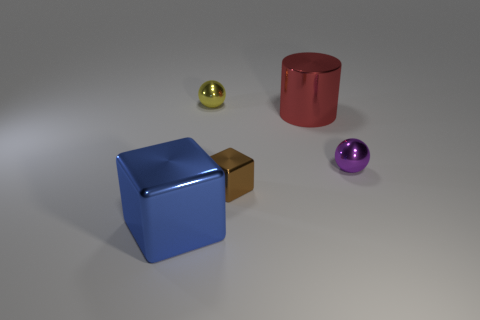Is there anything else that is the same color as the tiny metallic cube?
Make the answer very short. No. The shiny cylinder has what color?
Your response must be concise. Red. What number of metallic things are either tiny yellow spheres or tiny purple balls?
Make the answer very short. 2. The other small thing that is the same shape as the purple shiny thing is what color?
Make the answer very short. Yellow. Are there any green cubes?
Offer a very short reply. No. What number of objects are small purple spheres right of the small brown metallic object or tiny things left of the purple metallic sphere?
Provide a succinct answer. 3. There is a cube that is in front of the small brown shiny block; is it the same color as the tiny metal sphere that is on the right side of the tiny yellow ball?
Provide a succinct answer. No. There is a shiny object that is both to the left of the small brown metallic cube and behind the tiny purple thing; what shape is it?
Keep it short and to the point. Sphere. There is a metal block that is the same size as the purple metal object; what color is it?
Give a very brief answer. Brown. There is a sphere that is in front of the big red metal thing; is it the same size as the shiny block on the right side of the big blue cube?
Your answer should be very brief. Yes. 